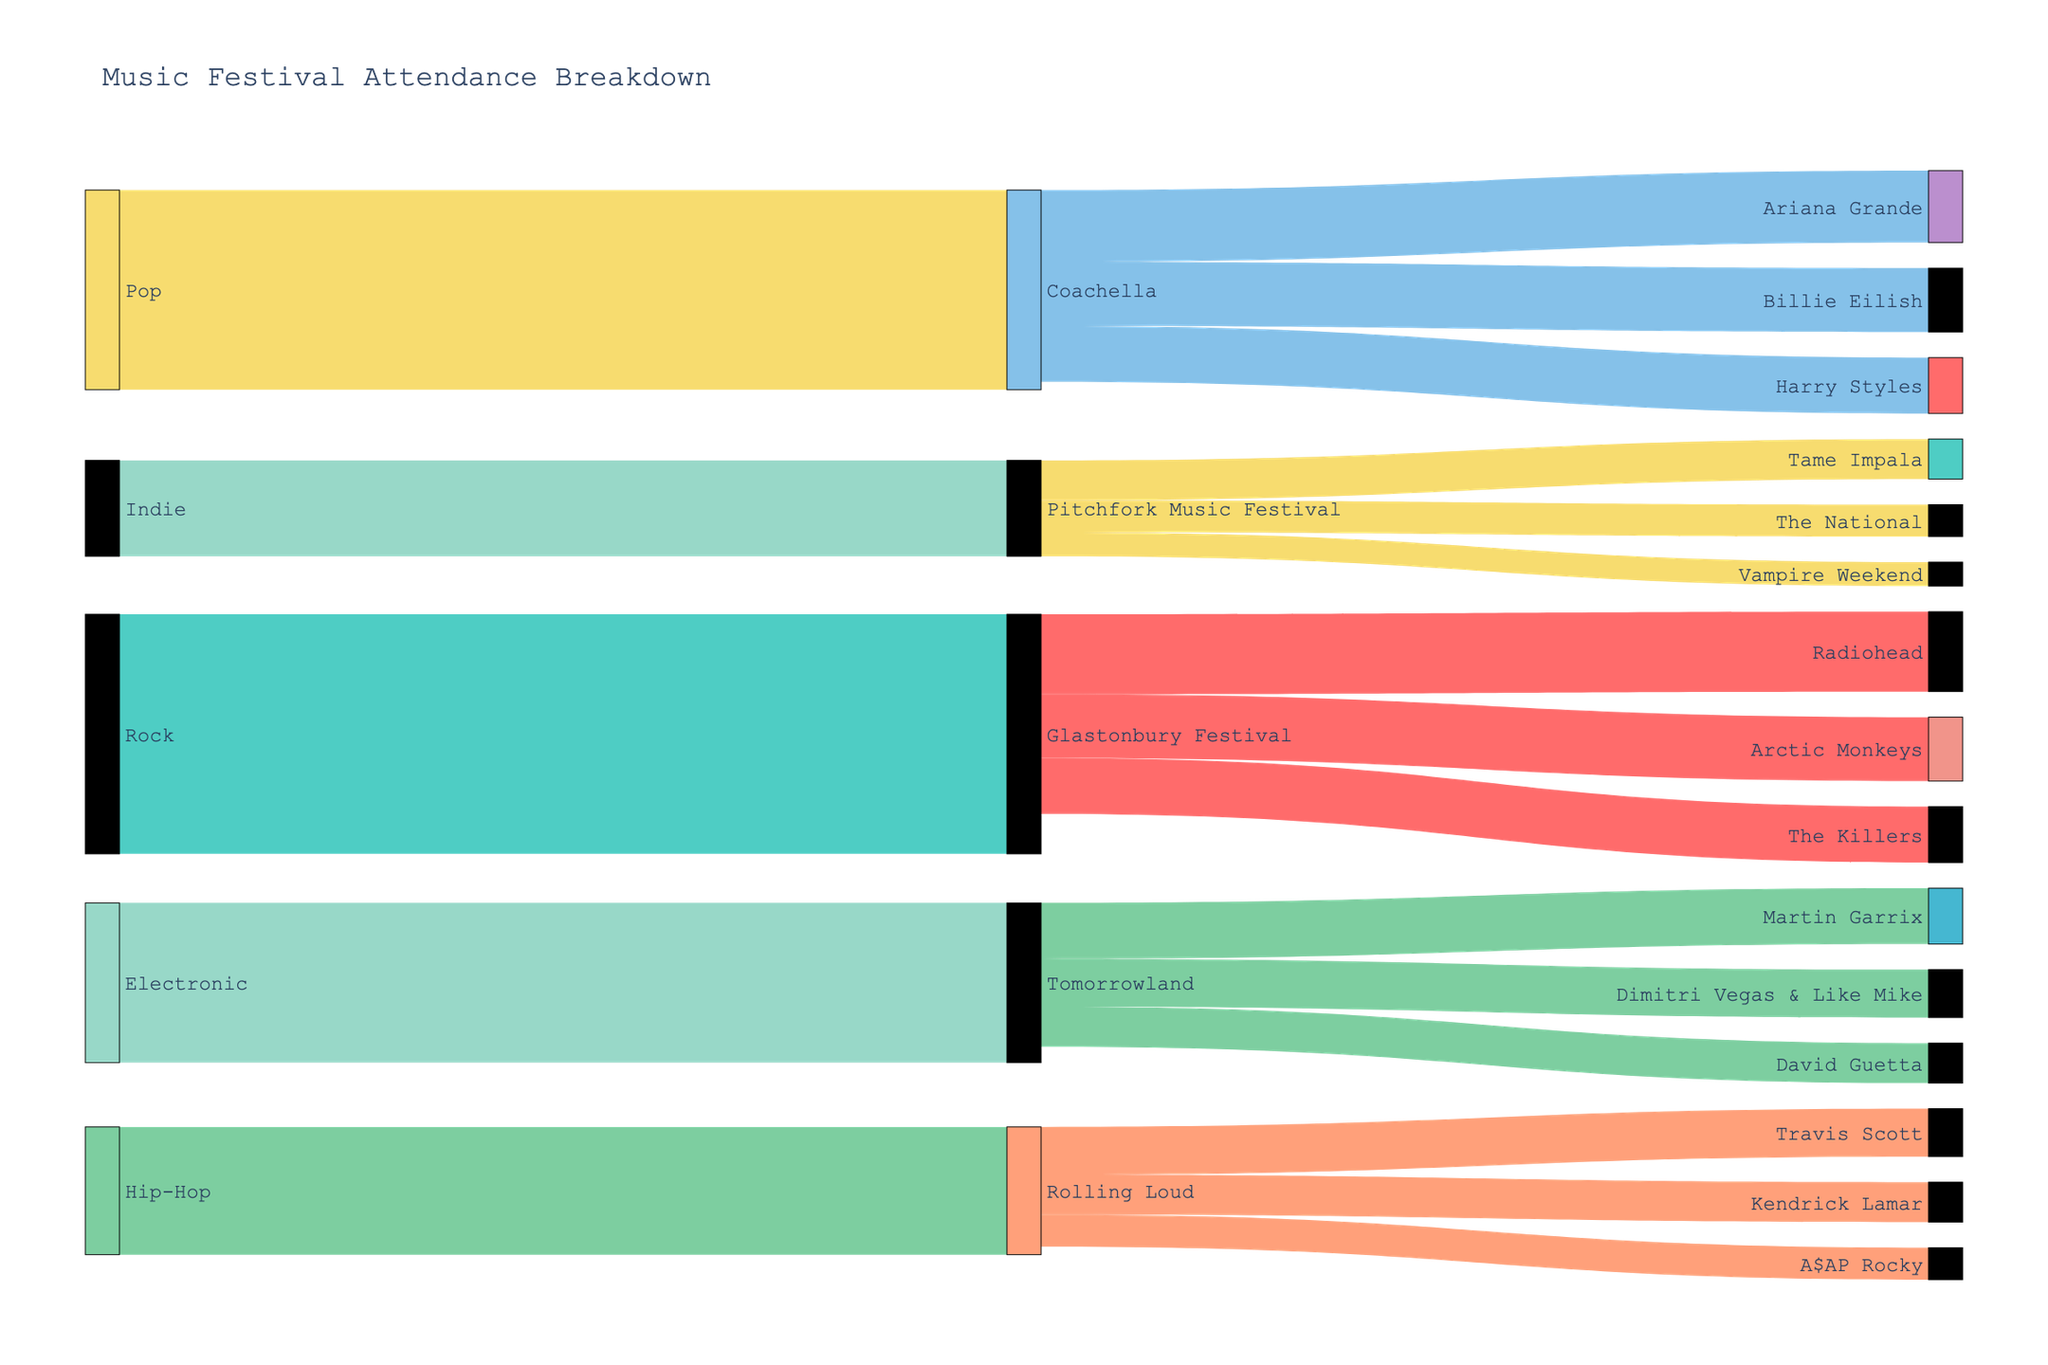what is the title of the figure? The title is usually positioned at the top of the figure. Read the text at the top that summarizes the content.
Answer: Music Festival Attendance Breakdown what are the five main music genres shown in the figure? Identify the nodes at the leftmost part of the Sankey diagram. These usually represent the first layer or the input categories.
Answer: Rock, Pop, Electronic, Hip-Hop, Indie which music festival has the highest attendance? Look at the width of the links connecting each genre to its corresponding festival on the right side. The widest link indicates the highest attendance.
Answer: Glastonbury Festival which artist at Coachella has the lowest attendance? Examine the links leading from Coachella to the artists. The link with the smallest width represents the lowest attendance.
Answer: Harry Styles what is the total attendance for Rock genre artists at Glastonbury Festival? Sum the values of the links connecting Glastonbury Festival to the Rock genre artists (Radiohead, Arctic Monkeys, and The Killers).
Answer: 125,000 which genre has the smallest total attendance at its associated festival? Identify the genre with the narrowest links leading to its festival.
Answer: Indie compare the total attendance at Tomorrowland with Rolling Loud. Which one has more? Add the attendance values for the artists at each festival and compare the totals. Tomorrowland: 35,000 + 30,000 + 25,000 = 90,000; Rolling Loud: 30,000 + 25,000 + 20,000 = 75,000.
Answer: Tomorrowland how does the attendance of Pitchfork Music Festival compare to Rolling Loud? Sum the values of the links leading to Pitchfork Music Festival and Rolling Loud, then compare them. Pitchfork: 25,000 + 20,000 + 15,000 = 60,000; Rolling Loud: 75,000.
Answer: Lower which artist at Glastonbury Festival has the highest attendance? Among the Rock genre artists at Glastonbury Festival, identify which link to the artist has the greatest width.
Answer: Radiohead 